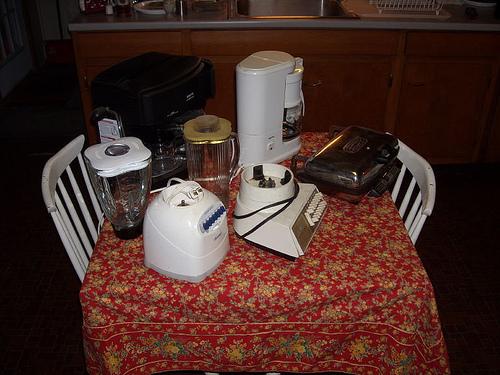How many chairs are visible?
Quick response, please. 2. Is the table covered?
Answer briefly. Yes. What room is this?
Concise answer only. Kitchen. What is on top of the table?
Be succinct. Appliances. What are these appliances for?
Keep it brief. Cooking. 